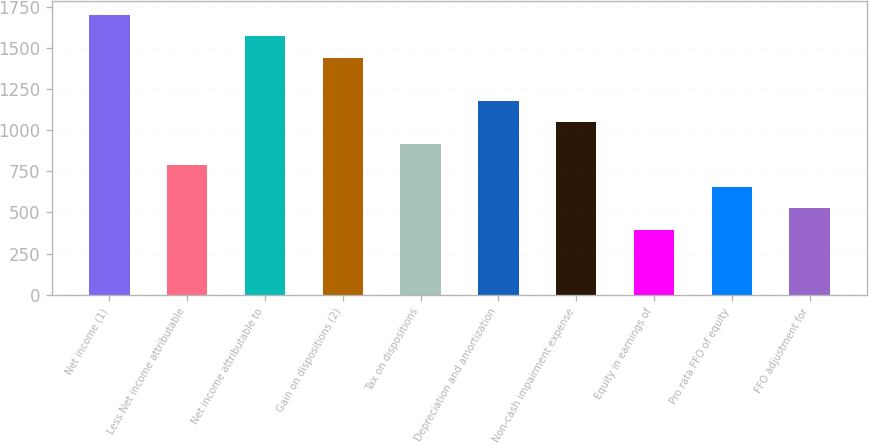<chart> <loc_0><loc_0><loc_500><loc_500><bar_chart><fcel>Net income (1)<fcel>Less Net income attributable<fcel>Net income attributable to<fcel>Gain on dispositions (2)<fcel>Tax on dispositions<fcel>Depreciation and amortization<fcel>Non-cash impairment expense<fcel>Equity in earnings of<fcel>Pro rata FFO of equity<fcel>FFO adjustment for<nl><fcel>1699.83<fcel>785.49<fcel>1569.21<fcel>1438.59<fcel>916.11<fcel>1177.35<fcel>1046.73<fcel>393.63<fcel>654.87<fcel>524.25<nl></chart> 